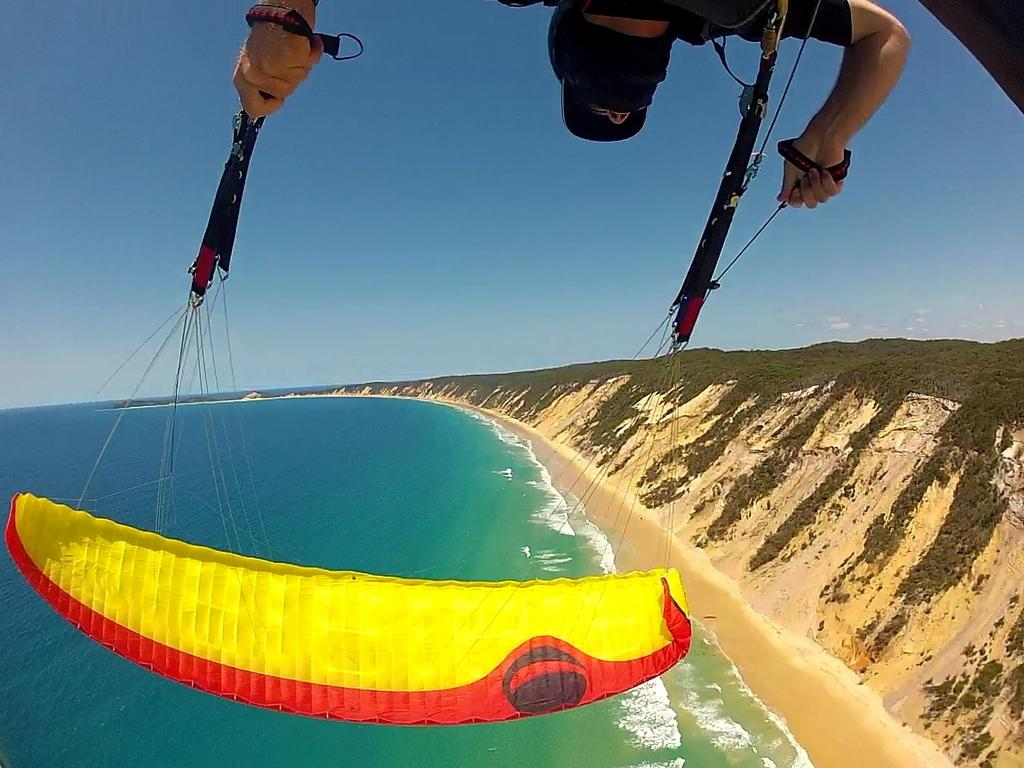What activity is the man in the image engaged in? The man in the image is doing paragliding. What can be seen on the ground in the image? There is water on the ground in the image. What type of landscape is visible in the background of the image? There are hills covered with trees in the image. How would you describe the sky in the image? The sky is clear in the image. What type of meat is the man eating while paragliding in the image? There is no meat present in the image, and the man is not eating while paragliding. 